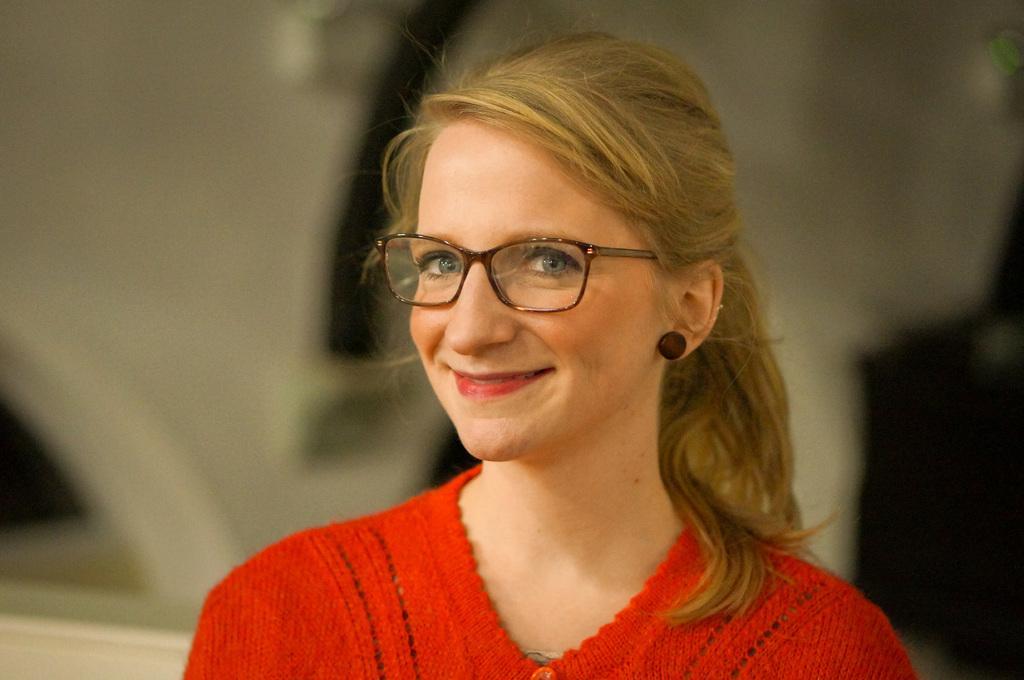Could you give a brief overview of what you see in this image? In the center of the image we can see a lady wearing a red dress. She is smiling. 